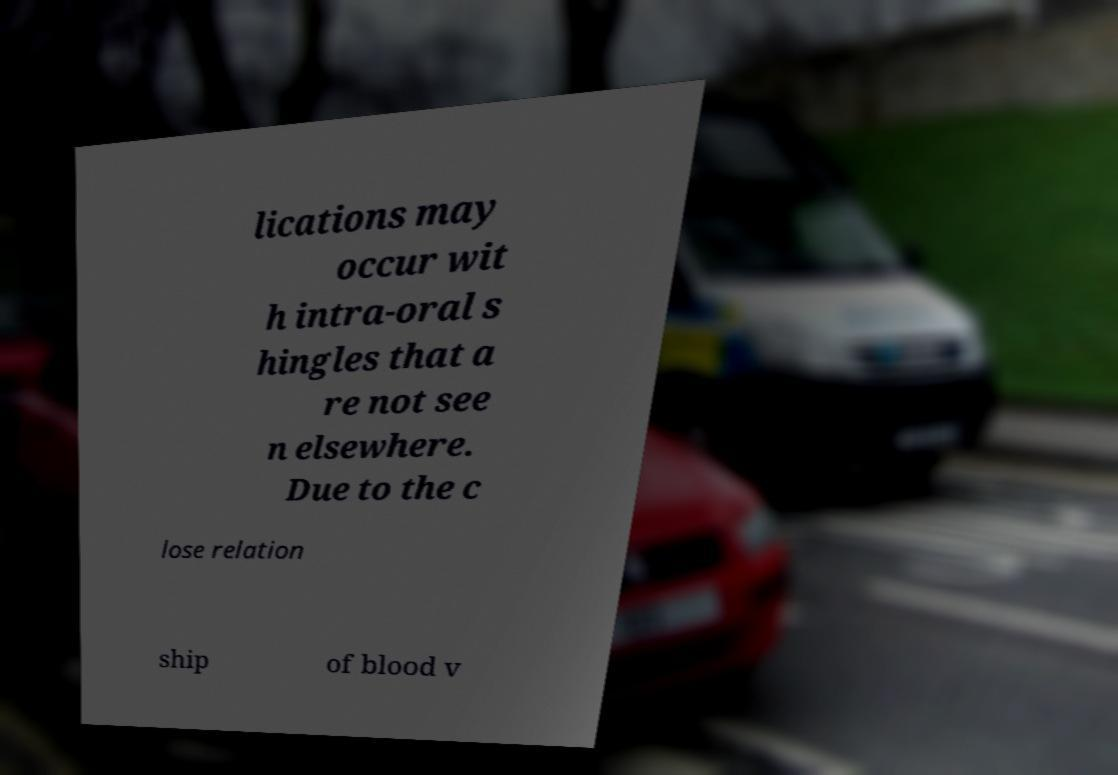For documentation purposes, I need the text within this image transcribed. Could you provide that? lications may occur wit h intra-oral s hingles that a re not see n elsewhere. Due to the c lose relation ship of blood v 